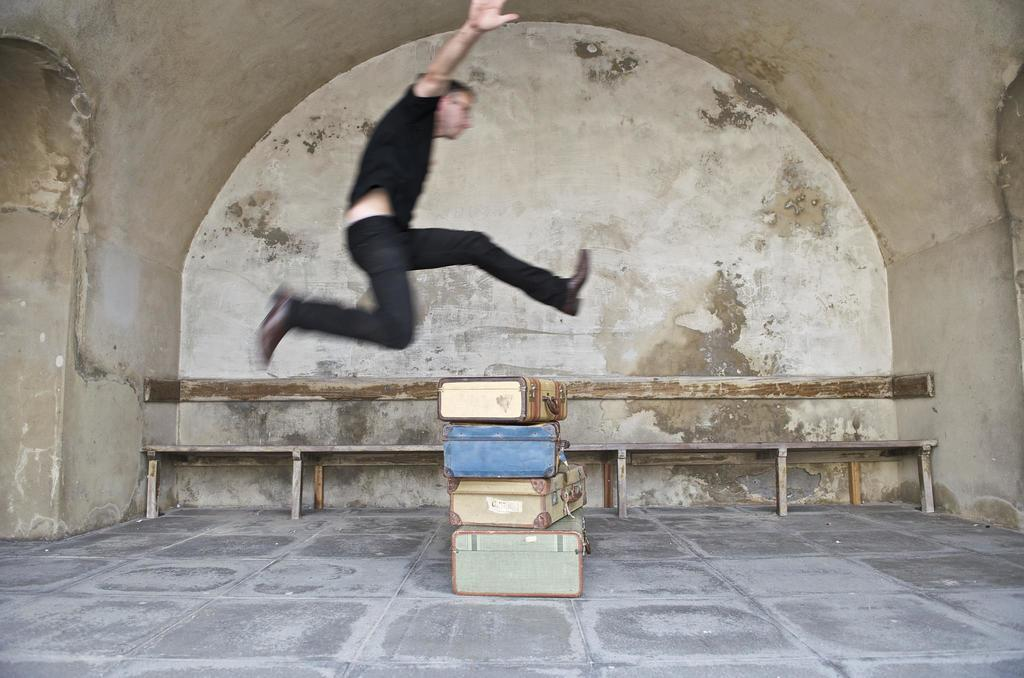Who is the main subject in the image? There is a man in the center of the image. What is the man wearing? The man is wearing a black shirt. What is the man doing in the image? The man is jumping over briefcases. What can be seen in the background of the image? There is a wall in the background of the image. Is there a woman in the image who appears to be in shock? There is no woman present in the image, and no one appears to be in shock. 